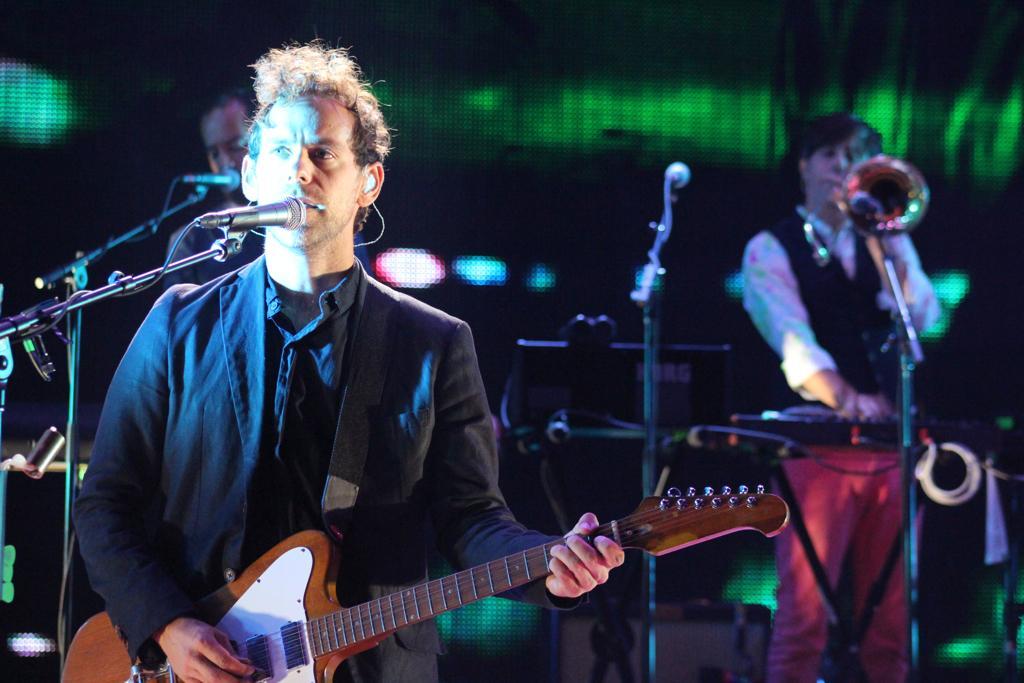In one or two sentences, can you explain what this image depicts? As we can see in the image there are few people standing and singing on mike and the person standing in front is holding guitar in his hands. 